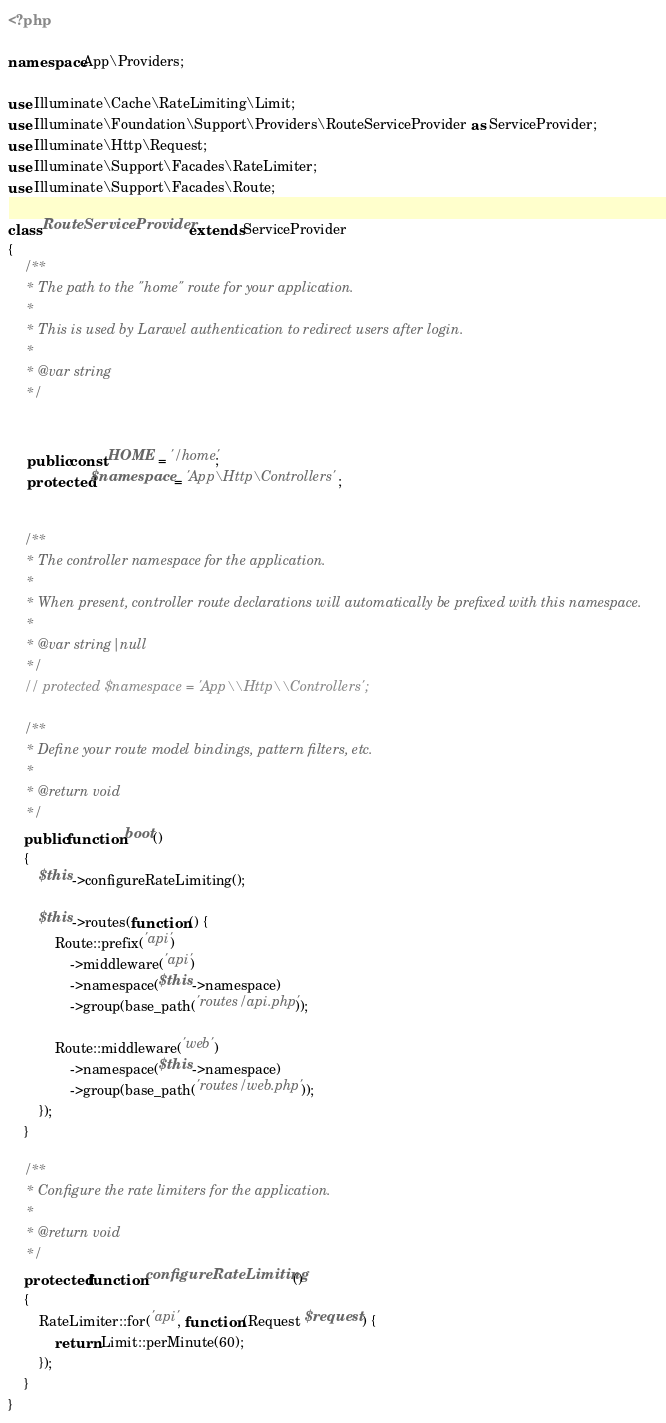<code> <loc_0><loc_0><loc_500><loc_500><_PHP_><?php

namespace App\Providers;

use Illuminate\Cache\RateLimiting\Limit;
use Illuminate\Foundation\Support\Providers\RouteServiceProvider as ServiceProvider;
use Illuminate\Http\Request;
use Illuminate\Support\Facades\RateLimiter;
use Illuminate\Support\Facades\Route;

class RouteServiceProvider extends ServiceProvider
{
    /**
     * The path to the "home" route for your application.
     *
     * This is used by Laravel authentication to redirect users after login.
     *
     * @var string
     */
    
    
     public const HOME = '/home';
     protected $namespace = 'App\Http\Controllers';


    /**
     * The controller namespace for the application.
     *
     * When present, controller route declarations will automatically be prefixed with this namespace.
     *
     * @var string|null
     */
    // protected $namespace = 'App\\Http\\Controllers';

    /**
     * Define your route model bindings, pattern filters, etc.
     *
     * @return void
     */
    public function boot()
    {
        $this->configureRateLimiting();

        $this->routes(function () {
            Route::prefix('api')
                ->middleware('api')
                ->namespace($this->namespace)
                ->group(base_path('routes/api.php'));

            Route::middleware('web')
                ->namespace($this->namespace)
                ->group(base_path('routes/web.php'));
        });
    }

    /**
     * Configure the rate limiters for the application.
     *
     * @return void
     */
    protected function configureRateLimiting()
    {
        RateLimiter::for('api', function (Request $request) {
            return Limit::perMinute(60);
        });
    }
}
</code> 